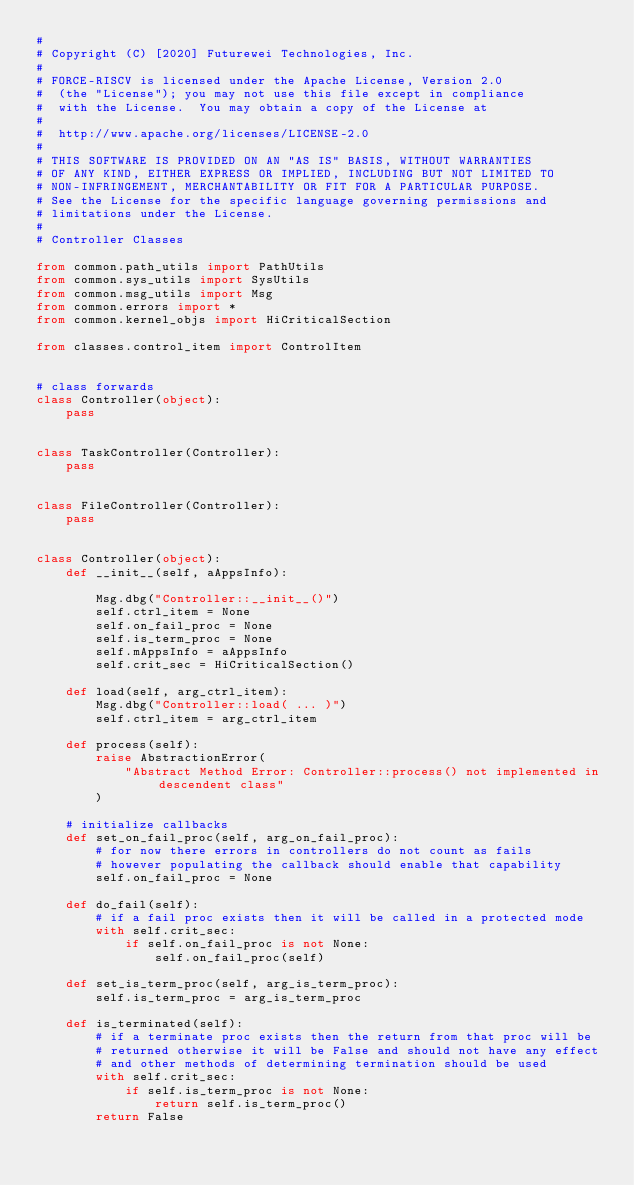<code> <loc_0><loc_0><loc_500><loc_500><_Python_>#
# Copyright (C) [2020] Futurewei Technologies, Inc.
#
# FORCE-RISCV is licensed under the Apache License, Version 2.0
#  (the "License"); you may not use this file except in compliance
#  with the License.  You may obtain a copy of the License at
#
#  http://www.apache.org/licenses/LICENSE-2.0
#
# THIS SOFTWARE IS PROVIDED ON AN "AS IS" BASIS, WITHOUT WARRANTIES
# OF ANY KIND, EITHER EXPRESS OR IMPLIED, INCLUDING BUT NOT LIMITED TO
# NON-INFRINGEMENT, MERCHANTABILITY OR FIT FOR A PARTICULAR PURPOSE.
# See the License for the specific language governing permissions and
# limitations under the License.
#
# Controller Classes

from common.path_utils import PathUtils
from common.sys_utils import SysUtils
from common.msg_utils import Msg
from common.errors import *
from common.kernel_objs import HiCriticalSection

from classes.control_item import ControlItem


# class forwards
class Controller(object):
    pass


class TaskController(Controller):
    pass


class FileController(Controller):
    pass


class Controller(object):
    def __init__(self, aAppsInfo):

        Msg.dbg("Controller::__init__()")
        self.ctrl_item = None
        self.on_fail_proc = None
        self.is_term_proc = None
        self.mAppsInfo = aAppsInfo
        self.crit_sec = HiCriticalSection()

    def load(self, arg_ctrl_item):
        Msg.dbg("Controller::load( ... )")
        self.ctrl_item = arg_ctrl_item

    def process(self):
        raise AbstractionError(
            "Abstract Method Error: Controller::process() not implemented in descendent class"
        )

    # initialize callbacks
    def set_on_fail_proc(self, arg_on_fail_proc):
        # for now there errors in controllers do not count as fails
        # however populating the callback should enable that capability
        self.on_fail_proc = None

    def do_fail(self):
        # if a fail proc exists then it will be called in a protected mode
        with self.crit_sec:
            if self.on_fail_proc is not None:
                self.on_fail_proc(self)

    def set_is_term_proc(self, arg_is_term_proc):
        self.is_term_proc = arg_is_term_proc

    def is_terminated(self):
        # if a terminate proc exists then the return from that proc will be
        # returned otherwise it will be False and should not have any effect
        # and other methods of determining termination should be used
        with self.crit_sec:
            if self.is_term_proc is not None:
                return self.is_term_proc()
        return False
</code> 